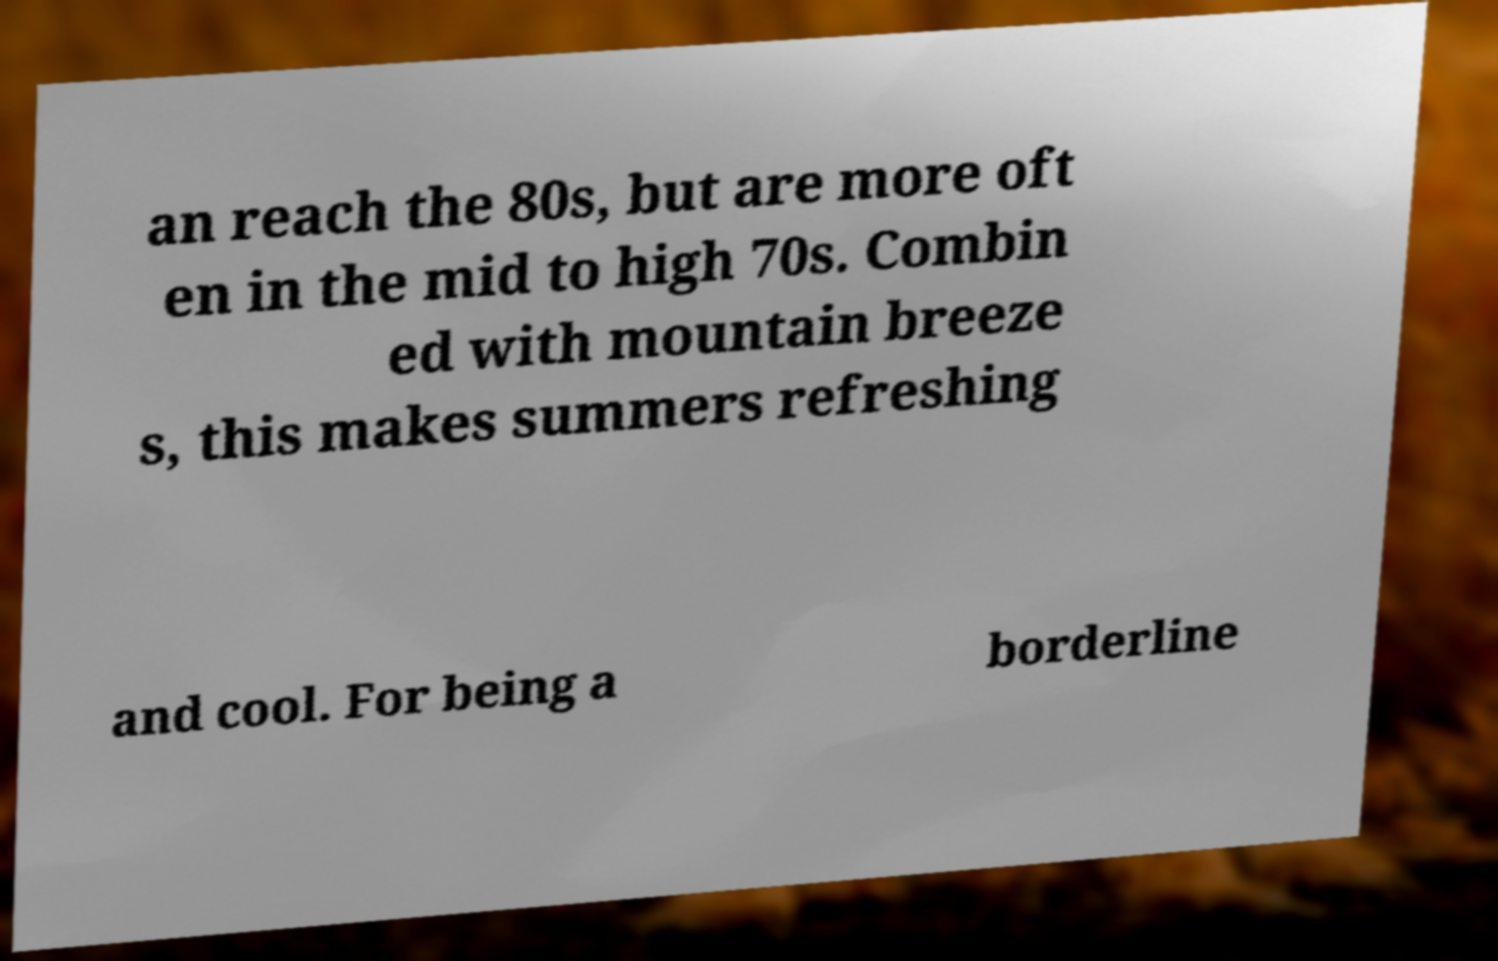Please identify and transcribe the text found in this image. an reach the 80s, but are more oft en in the mid to high 70s. Combin ed with mountain breeze s, this makes summers refreshing and cool. For being a borderline 